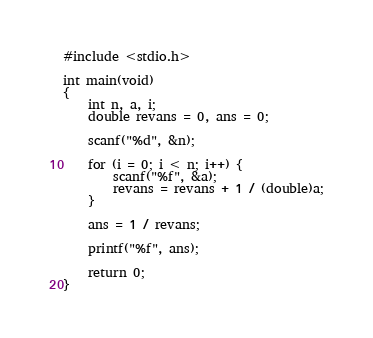<code> <loc_0><loc_0><loc_500><loc_500><_C_>#include <stdio.h>

int main(void)
{
	int n, a, i;
	double revans = 0, ans = 0;

	scanf("%d", &n);

	for (i = 0; i < n; i++) {
		scanf("%f", &a);
		revans = revans + 1 / (double)a;
	}

	ans = 1 / revans;

	printf("%f", ans);

	return 0;
}</code> 